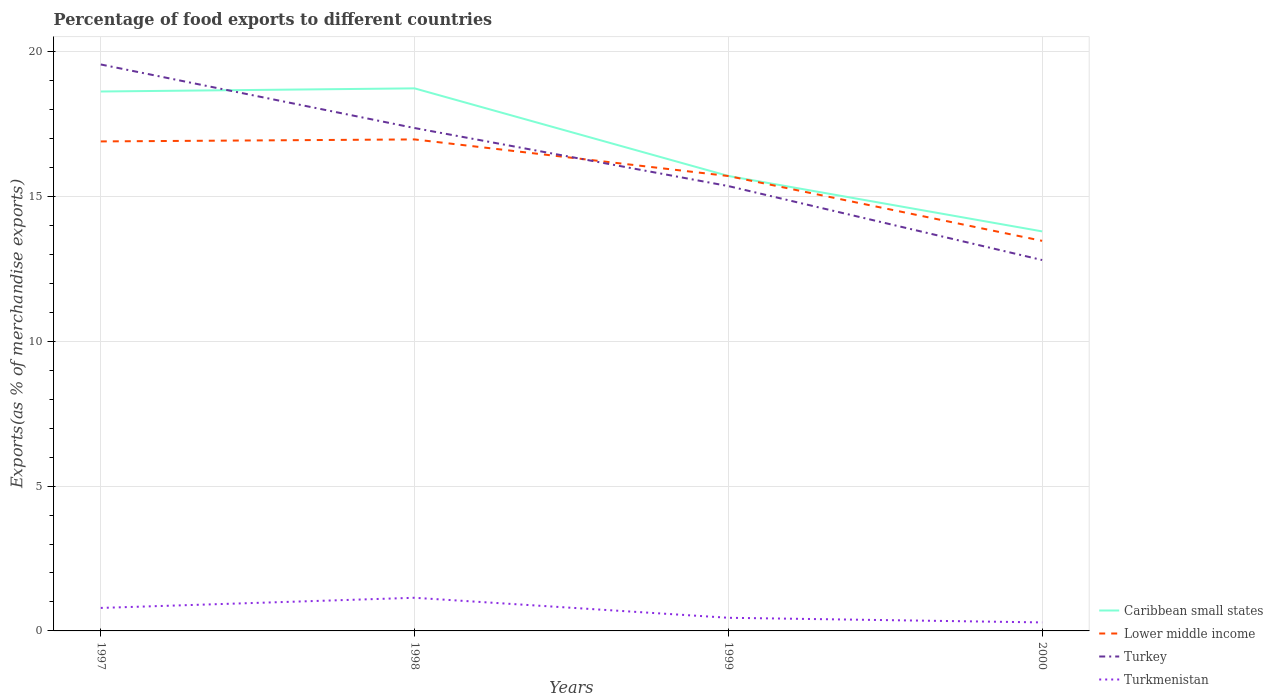Across all years, what is the maximum percentage of exports to different countries in Caribbean small states?
Give a very brief answer. 13.79. In which year was the percentage of exports to different countries in Turkey maximum?
Your answer should be very brief. 2000. What is the total percentage of exports to different countries in Caribbean small states in the graph?
Provide a short and direct response. 4.94. What is the difference between the highest and the second highest percentage of exports to different countries in Caribbean small states?
Provide a succinct answer. 4.94. Is the percentage of exports to different countries in Lower middle income strictly greater than the percentage of exports to different countries in Turkey over the years?
Make the answer very short. No. How many years are there in the graph?
Your answer should be very brief. 4. What is the difference between two consecutive major ticks on the Y-axis?
Provide a succinct answer. 5. Are the values on the major ticks of Y-axis written in scientific E-notation?
Offer a very short reply. No. Does the graph contain any zero values?
Provide a short and direct response. No. Does the graph contain grids?
Offer a very short reply. Yes. What is the title of the graph?
Make the answer very short. Percentage of food exports to different countries. Does "Low & middle income" appear as one of the legend labels in the graph?
Your answer should be compact. No. What is the label or title of the Y-axis?
Your answer should be very brief. Exports(as % of merchandise exports). What is the Exports(as % of merchandise exports) in Caribbean small states in 1997?
Give a very brief answer. 18.62. What is the Exports(as % of merchandise exports) of Lower middle income in 1997?
Offer a very short reply. 16.9. What is the Exports(as % of merchandise exports) in Turkey in 1997?
Ensure brevity in your answer.  19.55. What is the Exports(as % of merchandise exports) of Turkmenistan in 1997?
Ensure brevity in your answer.  0.79. What is the Exports(as % of merchandise exports) in Caribbean small states in 1998?
Make the answer very short. 18.73. What is the Exports(as % of merchandise exports) of Lower middle income in 1998?
Provide a short and direct response. 16.97. What is the Exports(as % of merchandise exports) of Turkey in 1998?
Your answer should be compact. 17.36. What is the Exports(as % of merchandise exports) of Turkmenistan in 1998?
Provide a succinct answer. 1.14. What is the Exports(as % of merchandise exports) in Caribbean small states in 1999?
Give a very brief answer. 15.71. What is the Exports(as % of merchandise exports) of Lower middle income in 1999?
Offer a very short reply. 15.7. What is the Exports(as % of merchandise exports) of Turkey in 1999?
Keep it short and to the point. 15.36. What is the Exports(as % of merchandise exports) in Turkmenistan in 1999?
Make the answer very short. 0.45. What is the Exports(as % of merchandise exports) of Caribbean small states in 2000?
Your answer should be compact. 13.79. What is the Exports(as % of merchandise exports) of Lower middle income in 2000?
Give a very brief answer. 13.47. What is the Exports(as % of merchandise exports) of Turkey in 2000?
Your response must be concise. 12.8. What is the Exports(as % of merchandise exports) of Turkmenistan in 2000?
Offer a terse response. 0.29. Across all years, what is the maximum Exports(as % of merchandise exports) of Caribbean small states?
Keep it short and to the point. 18.73. Across all years, what is the maximum Exports(as % of merchandise exports) in Lower middle income?
Give a very brief answer. 16.97. Across all years, what is the maximum Exports(as % of merchandise exports) of Turkey?
Offer a very short reply. 19.55. Across all years, what is the maximum Exports(as % of merchandise exports) of Turkmenistan?
Provide a short and direct response. 1.14. Across all years, what is the minimum Exports(as % of merchandise exports) in Caribbean small states?
Make the answer very short. 13.79. Across all years, what is the minimum Exports(as % of merchandise exports) in Lower middle income?
Your response must be concise. 13.47. Across all years, what is the minimum Exports(as % of merchandise exports) of Turkey?
Give a very brief answer. 12.8. Across all years, what is the minimum Exports(as % of merchandise exports) of Turkmenistan?
Give a very brief answer. 0.29. What is the total Exports(as % of merchandise exports) in Caribbean small states in the graph?
Ensure brevity in your answer.  66.85. What is the total Exports(as % of merchandise exports) of Lower middle income in the graph?
Your response must be concise. 63.04. What is the total Exports(as % of merchandise exports) in Turkey in the graph?
Your answer should be very brief. 65.08. What is the total Exports(as % of merchandise exports) in Turkmenistan in the graph?
Offer a terse response. 2.69. What is the difference between the Exports(as % of merchandise exports) in Caribbean small states in 1997 and that in 1998?
Give a very brief answer. -0.11. What is the difference between the Exports(as % of merchandise exports) of Lower middle income in 1997 and that in 1998?
Keep it short and to the point. -0.07. What is the difference between the Exports(as % of merchandise exports) of Turkey in 1997 and that in 1998?
Your answer should be compact. 2.19. What is the difference between the Exports(as % of merchandise exports) of Turkmenistan in 1997 and that in 1998?
Keep it short and to the point. -0.35. What is the difference between the Exports(as % of merchandise exports) in Caribbean small states in 1997 and that in 1999?
Offer a very short reply. 2.92. What is the difference between the Exports(as % of merchandise exports) in Lower middle income in 1997 and that in 1999?
Your answer should be compact. 1.19. What is the difference between the Exports(as % of merchandise exports) of Turkey in 1997 and that in 1999?
Provide a succinct answer. 4.2. What is the difference between the Exports(as % of merchandise exports) in Turkmenistan in 1997 and that in 1999?
Your answer should be compact. 0.34. What is the difference between the Exports(as % of merchandise exports) in Caribbean small states in 1997 and that in 2000?
Make the answer very short. 4.83. What is the difference between the Exports(as % of merchandise exports) in Lower middle income in 1997 and that in 2000?
Make the answer very short. 3.43. What is the difference between the Exports(as % of merchandise exports) in Turkey in 1997 and that in 2000?
Make the answer very short. 6.75. What is the difference between the Exports(as % of merchandise exports) of Turkmenistan in 1997 and that in 2000?
Your answer should be very brief. 0.5. What is the difference between the Exports(as % of merchandise exports) of Caribbean small states in 1998 and that in 1999?
Give a very brief answer. 3.02. What is the difference between the Exports(as % of merchandise exports) of Lower middle income in 1998 and that in 1999?
Your answer should be compact. 1.26. What is the difference between the Exports(as % of merchandise exports) in Turkey in 1998 and that in 1999?
Your answer should be compact. 2. What is the difference between the Exports(as % of merchandise exports) in Turkmenistan in 1998 and that in 1999?
Your answer should be compact. 0.69. What is the difference between the Exports(as % of merchandise exports) of Caribbean small states in 1998 and that in 2000?
Your answer should be very brief. 4.94. What is the difference between the Exports(as % of merchandise exports) of Lower middle income in 1998 and that in 2000?
Offer a terse response. 3.5. What is the difference between the Exports(as % of merchandise exports) in Turkey in 1998 and that in 2000?
Give a very brief answer. 4.56. What is the difference between the Exports(as % of merchandise exports) of Turkmenistan in 1998 and that in 2000?
Your answer should be compact. 0.85. What is the difference between the Exports(as % of merchandise exports) in Caribbean small states in 1999 and that in 2000?
Ensure brevity in your answer.  1.91. What is the difference between the Exports(as % of merchandise exports) of Lower middle income in 1999 and that in 2000?
Keep it short and to the point. 2.24. What is the difference between the Exports(as % of merchandise exports) of Turkey in 1999 and that in 2000?
Offer a terse response. 2.55. What is the difference between the Exports(as % of merchandise exports) of Turkmenistan in 1999 and that in 2000?
Make the answer very short. 0.16. What is the difference between the Exports(as % of merchandise exports) of Caribbean small states in 1997 and the Exports(as % of merchandise exports) of Lower middle income in 1998?
Your answer should be very brief. 1.65. What is the difference between the Exports(as % of merchandise exports) of Caribbean small states in 1997 and the Exports(as % of merchandise exports) of Turkey in 1998?
Keep it short and to the point. 1.26. What is the difference between the Exports(as % of merchandise exports) in Caribbean small states in 1997 and the Exports(as % of merchandise exports) in Turkmenistan in 1998?
Provide a short and direct response. 17.48. What is the difference between the Exports(as % of merchandise exports) of Lower middle income in 1997 and the Exports(as % of merchandise exports) of Turkey in 1998?
Keep it short and to the point. -0.46. What is the difference between the Exports(as % of merchandise exports) of Lower middle income in 1997 and the Exports(as % of merchandise exports) of Turkmenistan in 1998?
Keep it short and to the point. 15.75. What is the difference between the Exports(as % of merchandise exports) in Turkey in 1997 and the Exports(as % of merchandise exports) in Turkmenistan in 1998?
Offer a very short reply. 18.41. What is the difference between the Exports(as % of merchandise exports) in Caribbean small states in 1997 and the Exports(as % of merchandise exports) in Lower middle income in 1999?
Ensure brevity in your answer.  2.92. What is the difference between the Exports(as % of merchandise exports) in Caribbean small states in 1997 and the Exports(as % of merchandise exports) in Turkey in 1999?
Keep it short and to the point. 3.26. What is the difference between the Exports(as % of merchandise exports) of Caribbean small states in 1997 and the Exports(as % of merchandise exports) of Turkmenistan in 1999?
Give a very brief answer. 18.17. What is the difference between the Exports(as % of merchandise exports) in Lower middle income in 1997 and the Exports(as % of merchandise exports) in Turkey in 1999?
Provide a short and direct response. 1.54. What is the difference between the Exports(as % of merchandise exports) in Lower middle income in 1997 and the Exports(as % of merchandise exports) in Turkmenistan in 1999?
Give a very brief answer. 16.44. What is the difference between the Exports(as % of merchandise exports) of Turkey in 1997 and the Exports(as % of merchandise exports) of Turkmenistan in 1999?
Make the answer very short. 19.1. What is the difference between the Exports(as % of merchandise exports) in Caribbean small states in 1997 and the Exports(as % of merchandise exports) in Lower middle income in 2000?
Provide a short and direct response. 5.16. What is the difference between the Exports(as % of merchandise exports) in Caribbean small states in 1997 and the Exports(as % of merchandise exports) in Turkey in 2000?
Provide a short and direct response. 5.82. What is the difference between the Exports(as % of merchandise exports) of Caribbean small states in 1997 and the Exports(as % of merchandise exports) of Turkmenistan in 2000?
Keep it short and to the point. 18.33. What is the difference between the Exports(as % of merchandise exports) of Lower middle income in 1997 and the Exports(as % of merchandise exports) of Turkey in 2000?
Keep it short and to the point. 4.09. What is the difference between the Exports(as % of merchandise exports) of Lower middle income in 1997 and the Exports(as % of merchandise exports) of Turkmenistan in 2000?
Ensure brevity in your answer.  16.6. What is the difference between the Exports(as % of merchandise exports) in Turkey in 1997 and the Exports(as % of merchandise exports) in Turkmenistan in 2000?
Provide a short and direct response. 19.26. What is the difference between the Exports(as % of merchandise exports) of Caribbean small states in 1998 and the Exports(as % of merchandise exports) of Lower middle income in 1999?
Provide a short and direct response. 3.03. What is the difference between the Exports(as % of merchandise exports) of Caribbean small states in 1998 and the Exports(as % of merchandise exports) of Turkey in 1999?
Provide a short and direct response. 3.37. What is the difference between the Exports(as % of merchandise exports) of Caribbean small states in 1998 and the Exports(as % of merchandise exports) of Turkmenistan in 1999?
Offer a very short reply. 18.28. What is the difference between the Exports(as % of merchandise exports) in Lower middle income in 1998 and the Exports(as % of merchandise exports) in Turkey in 1999?
Offer a terse response. 1.61. What is the difference between the Exports(as % of merchandise exports) in Lower middle income in 1998 and the Exports(as % of merchandise exports) in Turkmenistan in 1999?
Offer a very short reply. 16.51. What is the difference between the Exports(as % of merchandise exports) in Turkey in 1998 and the Exports(as % of merchandise exports) in Turkmenistan in 1999?
Provide a succinct answer. 16.91. What is the difference between the Exports(as % of merchandise exports) in Caribbean small states in 1998 and the Exports(as % of merchandise exports) in Lower middle income in 2000?
Make the answer very short. 5.26. What is the difference between the Exports(as % of merchandise exports) in Caribbean small states in 1998 and the Exports(as % of merchandise exports) in Turkey in 2000?
Your answer should be compact. 5.93. What is the difference between the Exports(as % of merchandise exports) in Caribbean small states in 1998 and the Exports(as % of merchandise exports) in Turkmenistan in 2000?
Make the answer very short. 18.44. What is the difference between the Exports(as % of merchandise exports) in Lower middle income in 1998 and the Exports(as % of merchandise exports) in Turkey in 2000?
Your answer should be compact. 4.16. What is the difference between the Exports(as % of merchandise exports) of Lower middle income in 1998 and the Exports(as % of merchandise exports) of Turkmenistan in 2000?
Your answer should be very brief. 16.67. What is the difference between the Exports(as % of merchandise exports) in Turkey in 1998 and the Exports(as % of merchandise exports) in Turkmenistan in 2000?
Your answer should be very brief. 17.07. What is the difference between the Exports(as % of merchandise exports) in Caribbean small states in 1999 and the Exports(as % of merchandise exports) in Lower middle income in 2000?
Make the answer very short. 2.24. What is the difference between the Exports(as % of merchandise exports) in Caribbean small states in 1999 and the Exports(as % of merchandise exports) in Turkey in 2000?
Your response must be concise. 2.9. What is the difference between the Exports(as % of merchandise exports) in Caribbean small states in 1999 and the Exports(as % of merchandise exports) in Turkmenistan in 2000?
Make the answer very short. 15.41. What is the difference between the Exports(as % of merchandise exports) of Lower middle income in 1999 and the Exports(as % of merchandise exports) of Turkey in 2000?
Make the answer very short. 2.9. What is the difference between the Exports(as % of merchandise exports) in Lower middle income in 1999 and the Exports(as % of merchandise exports) in Turkmenistan in 2000?
Give a very brief answer. 15.41. What is the difference between the Exports(as % of merchandise exports) in Turkey in 1999 and the Exports(as % of merchandise exports) in Turkmenistan in 2000?
Offer a very short reply. 15.06. What is the average Exports(as % of merchandise exports) in Caribbean small states per year?
Offer a very short reply. 16.71. What is the average Exports(as % of merchandise exports) in Lower middle income per year?
Provide a succinct answer. 15.76. What is the average Exports(as % of merchandise exports) in Turkey per year?
Provide a short and direct response. 16.27. What is the average Exports(as % of merchandise exports) in Turkmenistan per year?
Keep it short and to the point. 0.67. In the year 1997, what is the difference between the Exports(as % of merchandise exports) of Caribbean small states and Exports(as % of merchandise exports) of Lower middle income?
Ensure brevity in your answer.  1.72. In the year 1997, what is the difference between the Exports(as % of merchandise exports) in Caribbean small states and Exports(as % of merchandise exports) in Turkey?
Provide a short and direct response. -0.93. In the year 1997, what is the difference between the Exports(as % of merchandise exports) in Caribbean small states and Exports(as % of merchandise exports) in Turkmenistan?
Your answer should be very brief. 17.83. In the year 1997, what is the difference between the Exports(as % of merchandise exports) of Lower middle income and Exports(as % of merchandise exports) of Turkey?
Ensure brevity in your answer.  -2.66. In the year 1997, what is the difference between the Exports(as % of merchandise exports) in Lower middle income and Exports(as % of merchandise exports) in Turkmenistan?
Your response must be concise. 16.1. In the year 1997, what is the difference between the Exports(as % of merchandise exports) in Turkey and Exports(as % of merchandise exports) in Turkmenistan?
Your answer should be compact. 18.76. In the year 1998, what is the difference between the Exports(as % of merchandise exports) of Caribbean small states and Exports(as % of merchandise exports) of Lower middle income?
Provide a succinct answer. 1.76. In the year 1998, what is the difference between the Exports(as % of merchandise exports) in Caribbean small states and Exports(as % of merchandise exports) in Turkey?
Give a very brief answer. 1.37. In the year 1998, what is the difference between the Exports(as % of merchandise exports) in Caribbean small states and Exports(as % of merchandise exports) in Turkmenistan?
Offer a terse response. 17.59. In the year 1998, what is the difference between the Exports(as % of merchandise exports) of Lower middle income and Exports(as % of merchandise exports) of Turkey?
Your response must be concise. -0.39. In the year 1998, what is the difference between the Exports(as % of merchandise exports) of Lower middle income and Exports(as % of merchandise exports) of Turkmenistan?
Ensure brevity in your answer.  15.82. In the year 1998, what is the difference between the Exports(as % of merchandise exports) in Turkey and Exports(as % of merchandise exports) in Turkmenistan?
Give a very brief answer. 16.22. In the year 1999, what is the difference between the Exports(as % of merchandise exports) in Caribbean small states and Exports(as % of merchandise exports) in Lower middle income?
Your response must be concise. 0. In the year 1999, what is the difference between the Exports(as % of merchandise exports) in Caribbean small states and Exports(as % of merchandise exports) in Turkey?
Offer a terse response. 0.35. In the year 1999, what is the difference between the Exports(as % of merchandise exports) in Caribbean small states and Exports(as % of merchandise exports) in Turkmenistan?
Provide a short and direct response. 15.25. In the year 1999, what is the difference between the Exports(as % of merchandise exports) in Lower middle income and Exports(as % of merchandise exports) in Turkey?
Offer a very short reply. 0.35. In the year 1999, what is the difference between the Exports(as % of merchandise exports) in Lower middle income and Exports(as % of merchandise exports) in Turkmenistan?
Provide a succinct answer. 15.25. In the year 1999, what is the difference between the Exports(as % of merchandise exports) in Turkey and Exports(as % of merchandise exports) in Turkmenistan?
Offer a very short reply. 14.9. In the year 2000, what is the difference between the Exports(as % of merchandise exports) in Caribbean small states and Exports(as % of merchandise exports) in Lower middle income?
Your answer should be very brief. 0.33. In the year 2000, what is the difference between the Exports(as % of merchandise exports) in Caribbean small states and Exports(as % of merchandise exports) in Turkmenistan?
Ensure brevity in your answer.  13.5. In the year 2000, what is the difference between the Exports(as % of merchandise exports) in Lower middle income and Exports(as % of merchandise exports) in Turkey?
Your answer should be compact. 0.66. In the year 2000, what is the difference between the Exports(as % of merchandise exports) in Lower middle income and Exports(as % of merchandise exports) in Turkmenistan?
Your answer should be very brief. 13.17. In the year 2000, what is the difference between the Exports(as % of merchandise exports) in Turkey and Exports(as % of merchandise exports) in Turkmenistan?
Your answer should be compact. 12.51. What is the ratio of the Exports(as % of merchandise exports) in Lower middle income in 1997 to that in 1998?
Offer a terse response. 1. What is the ratio of the Exports(as % of merchandise exports) in Turkey in 1997 to that in 1998?
Provide a succinct answer. 1.13. What is the ratio of the Exports(as % of merchandise exports) of Turkmenistan in 1997 to that in 1998?
Keep it short and to the point. 0.69. What is the ratio of the Exports(as % of merchandise exports) in Caribbean small states in 1997 to that in 1999?
Provide a short and direct response. 1.19. What is the ratio of the Exports(as % of merchandise exports) of Lower middle income in 1997 to that in 1999?
Offer a terse response. 1.08. What is the ratio of the Exports(as % of merchandise exports) in Turkey in 1997 to that in 1999?
Provide a short and direct response. 1.27. What is the ratio of the Exports(as % of merchandise exports) of Turkmenistan in 1997 to that in 1999?
Provide a succinct answer. 1.75. What is the ratio of the Exports(as % of merchandise exports) of Caribbean small states in 1997 to that in 2000?
Offer a very short reply. 1.35. What is the ratio of the Exports(as % of merchandise exports) of Lower middle income in 1997 to that in 2000?
Provide a short and direct response. 1.25. What is the ratio of the Exports(as % of merchandise exports) in Turkey in 1997 to that in 2000?
Make the answer very short. 1.53. What is the ratio of the Exports(as % of merchandise exports) of Turkmenistan in 1997 to that in 2000?
Offer a very short reply. 2.7. What is the ratio of the Exports(as % of merchandise exports) in Caribbean small states in 1998 to that in 1999?
Offer a terse response. 1.19. What is the ratio of the Exports(as % of merchandise exports) of Lower middle income in 1998 to that in 1999?
Your answer should be compact. 1.08. What is the ratio of the Exports(as % of merchandise exports) of Turkey in 1998 to that in 1999?
Your answer should be compact. 1.13. What is the ratio of the Exports(as % of merchandise exports) of Turkmenistan in 1998 to that in 1999?
Your answer should be compact. 2.52. What is the ratio of the Exports(as % of merchandise exports) of Caribbean small states in 1998 to that in 2000?
Give a very brief answer. 1.36. What is the ratio of the Exports(as % of merchandise exports) of Lower middle income in 1998 to that in 2000?
Your response must be concise. 1.26. What is the ratio of the Exports(as % of merchandise exports) of Turkey in 1998 to that in 2000?
Provide a short and direct response. 1.36. What is the ratio of the Exports(as % of merchandise exports) of Turkmenistan in 1998 to that in 2000?
Your answer should be very brief. 3.9. What is the ratio of the Exports(as % of merchandise exports) in Caribbean small states in 1999 to that in 2000?
Provide a succinct answer. 1.14. What is the ratio of the Exports(as % of merchandise exports) in Lower middle income in 1999 to that in 2000?
Your answer should be compact. 1.17. What is the ratio of the Exports(as % of merchandise exports) of Turkey in 1999 to that in 2000?
Keep it short and to the point. 1.2. What is the ratio of the Exports(as % of merchandise exports) in Turkmenistan in 1999 to that in 2000?
Provide a succinct answer. 1.54. What is the difference between the highest and the second highest Exports(as % of merchandise exports) in Caribbean small states?
Provide a short and direct response. 0.11. What is the difference between the highest and the second highest Exports(as % of merchandise exports) in Lower middle income?
Your answer should be compact. 0.07. What is the difference between the highest and the second highest Exports(as % of merchandise exports) of Turkey?
Provide a short and direct response. 2.19. What is the difference between the highest and the second highest Exports(as % of merchandise exports) in Turkmenistan?
Your response must be concise. 0.35. What is the difference between the highest and the lowest Exports(as % of merchandise exports) of Caribbean small states?
Ensure brevity in your answer.  4.94. What is the difference between the highest and the lowest Exports(as % of merchandise exports) of Lower middle income?
Offer a very short reply. 3.5. What is the difference between the highest and the lowest Exports(as % of merchandise exports) in Turkey?
Keep it short and to the point. 6.75. What is the difference between the highest and the lowest Exports(as % of merchandise exports) of Turkmenistan?
Give a very brief answer. 0.85. 